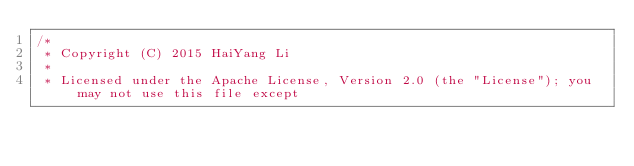<code> <loc_0><loc_0><loc_500><loc_500><_Java_>/*
 * Copyright (C) 2015 HaiYang Li
 *
 * Licensed under the Apache License, Version 2.0 (the "License"); you may not use this file except</code> 